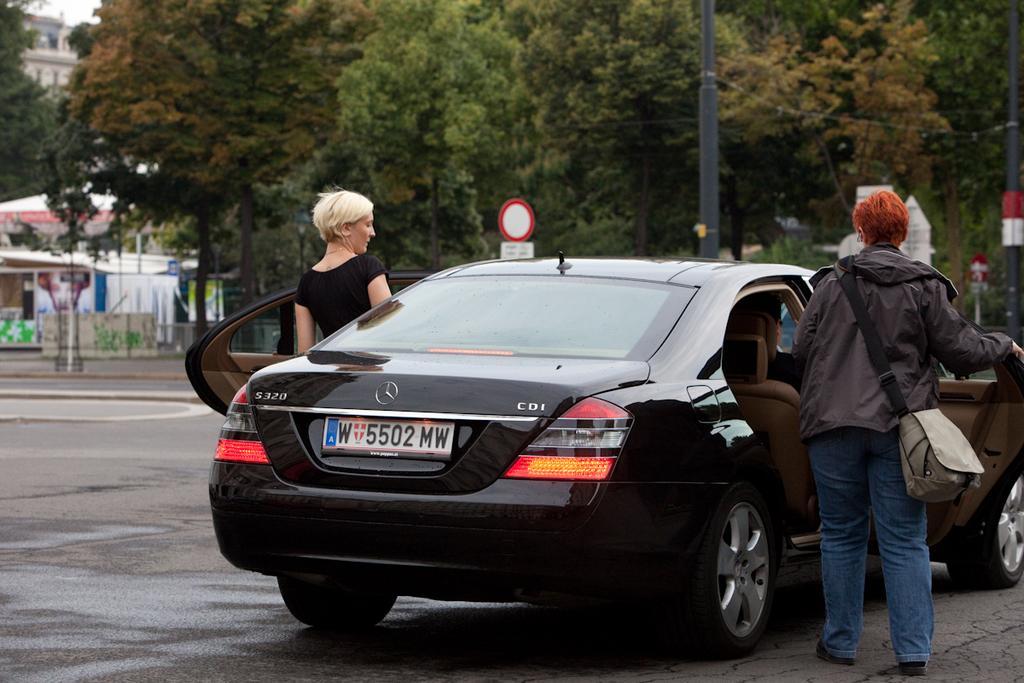Describe this image in one or two sentences. In this image there are two person entering into the car. At the back side there is a tree and a building. 